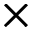<formula> <loc_0><loc_0><loc_500><loc_500>\times</formula> 